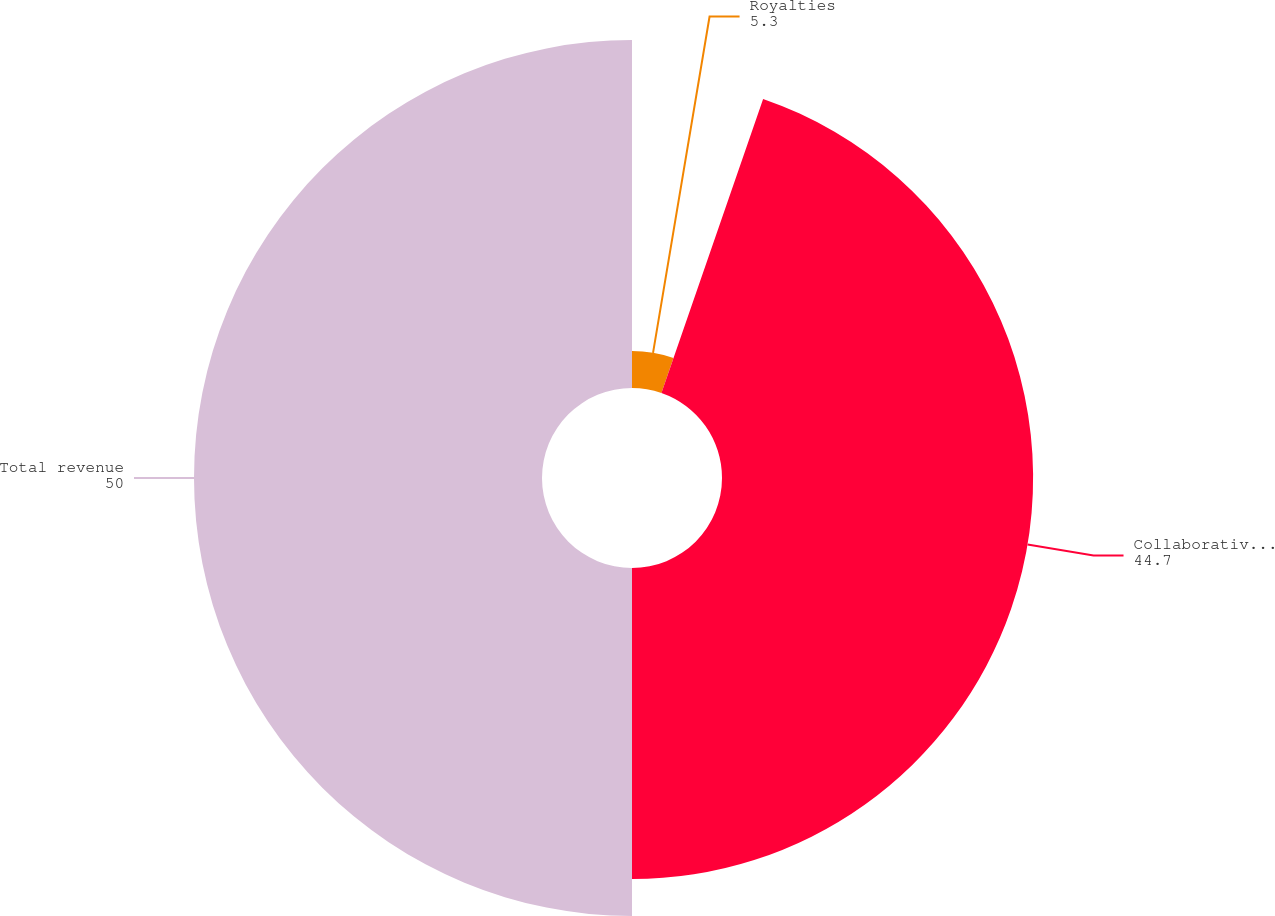Convert chart to OTSL. <chart><loc_0><loc_0><loc_500><loc_500><pie_chart><fcel>Royalties<fcel>Collaborative and other<fcel>Total revenue<nl><fcel>5.3%<fcel>44.7%<fcel>50.0%<nl></chart> 